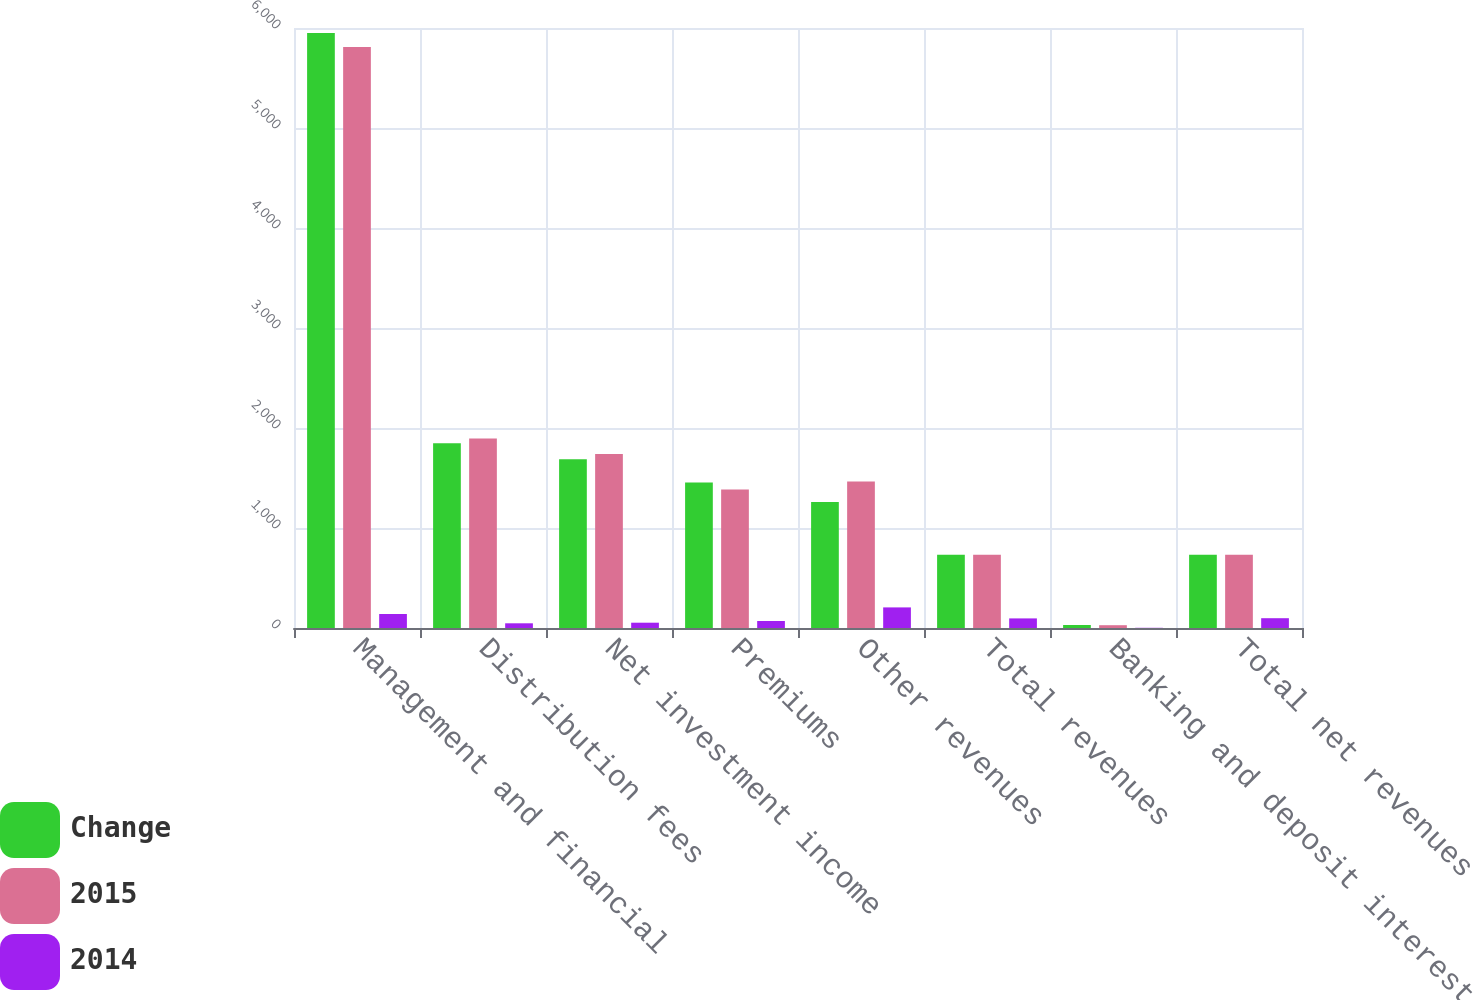Convert chart. <chart><loc_0><loc_0><loc_500><loc_500><stacked_bar_chart><ecel><fcel>Management and financial<fcel>Distribution fees<fcel>Net investment income<fcel>Premiums<fcel>Other revenues<fcel>Total revenues<fcel>Banking and deposit interest<fcel>Total net revenues<nl><fcel>Change<fcel>5950<fcel>1847<fcel>1688<fcel>1455<fcel>1260<fcel>733<fcel>30<fcel>733<nl><fcel>2015<fcel>5810<fcel>1894<fcel>1741<fcel>1385<fcel>1466<fcel>733<fcel>28<fcel>733<nl><fcel>2014<fcel>140<fcel>47<fcel>53<fcel>70<fcel>206<fcel>96<fcel>2<fcel>98<nl></chart> 